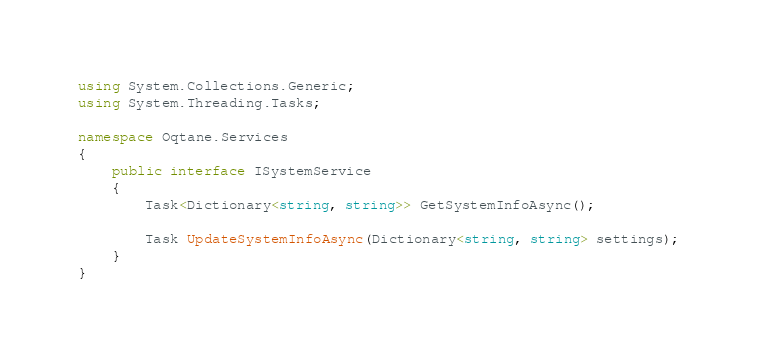Convert code to text. <code><loc_0><loc_0><loc_500><loc_500><_C#_>using System.Collections.Generic;
using System.Threading.Tasks;

namespace Oqtane.Services
{
    public interface ISystemService
    {
        Task<Dictionary<string, string>> GetSystemInfoAsync();

        Task UpdateSystemInfoAsync(Dictionary<string, string> settings);
    }
}
</code> 